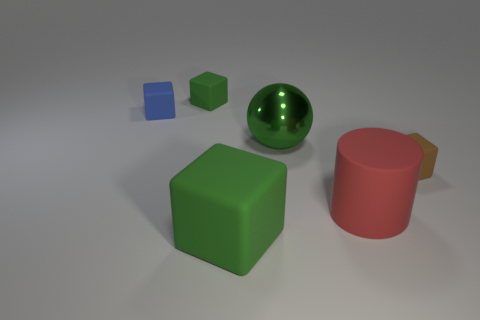Subtract 1 blocks. How many blocks are left? 3 Add 1 purple metallic cylinders. How many objects exist? 7 Subtract all balls. How many objects are left? 5 Subtract all blue balls. Subtract all small brown rubber things. How many objects are left? 5 Add 2 big red rubber objects. How many big red rubber objects are left? 3 Add 4 metallic spheres. How many metallic spheres exist? 5 Subtract 0 yellow cylinders. How many objects are left? 6 